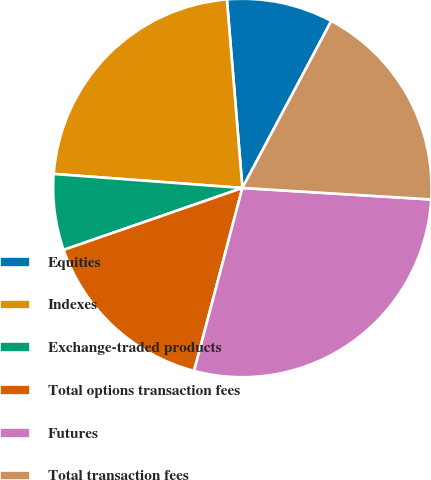Convert chart. <chart><loc_0><loc_0><loc_500><loc_500><pie_chart><fcel>Equities<fcel>Indexes<fcel>Exchange-traded products<fcel>Total options transaction fees<fcel>Futures<fcel>Total transaction fees<nl><fcel>9.09%<fcel>22.51%<fcel>6.49%<fcel>15.58%<fcel>28.14%<fcel>18.18%<nl></chart> 